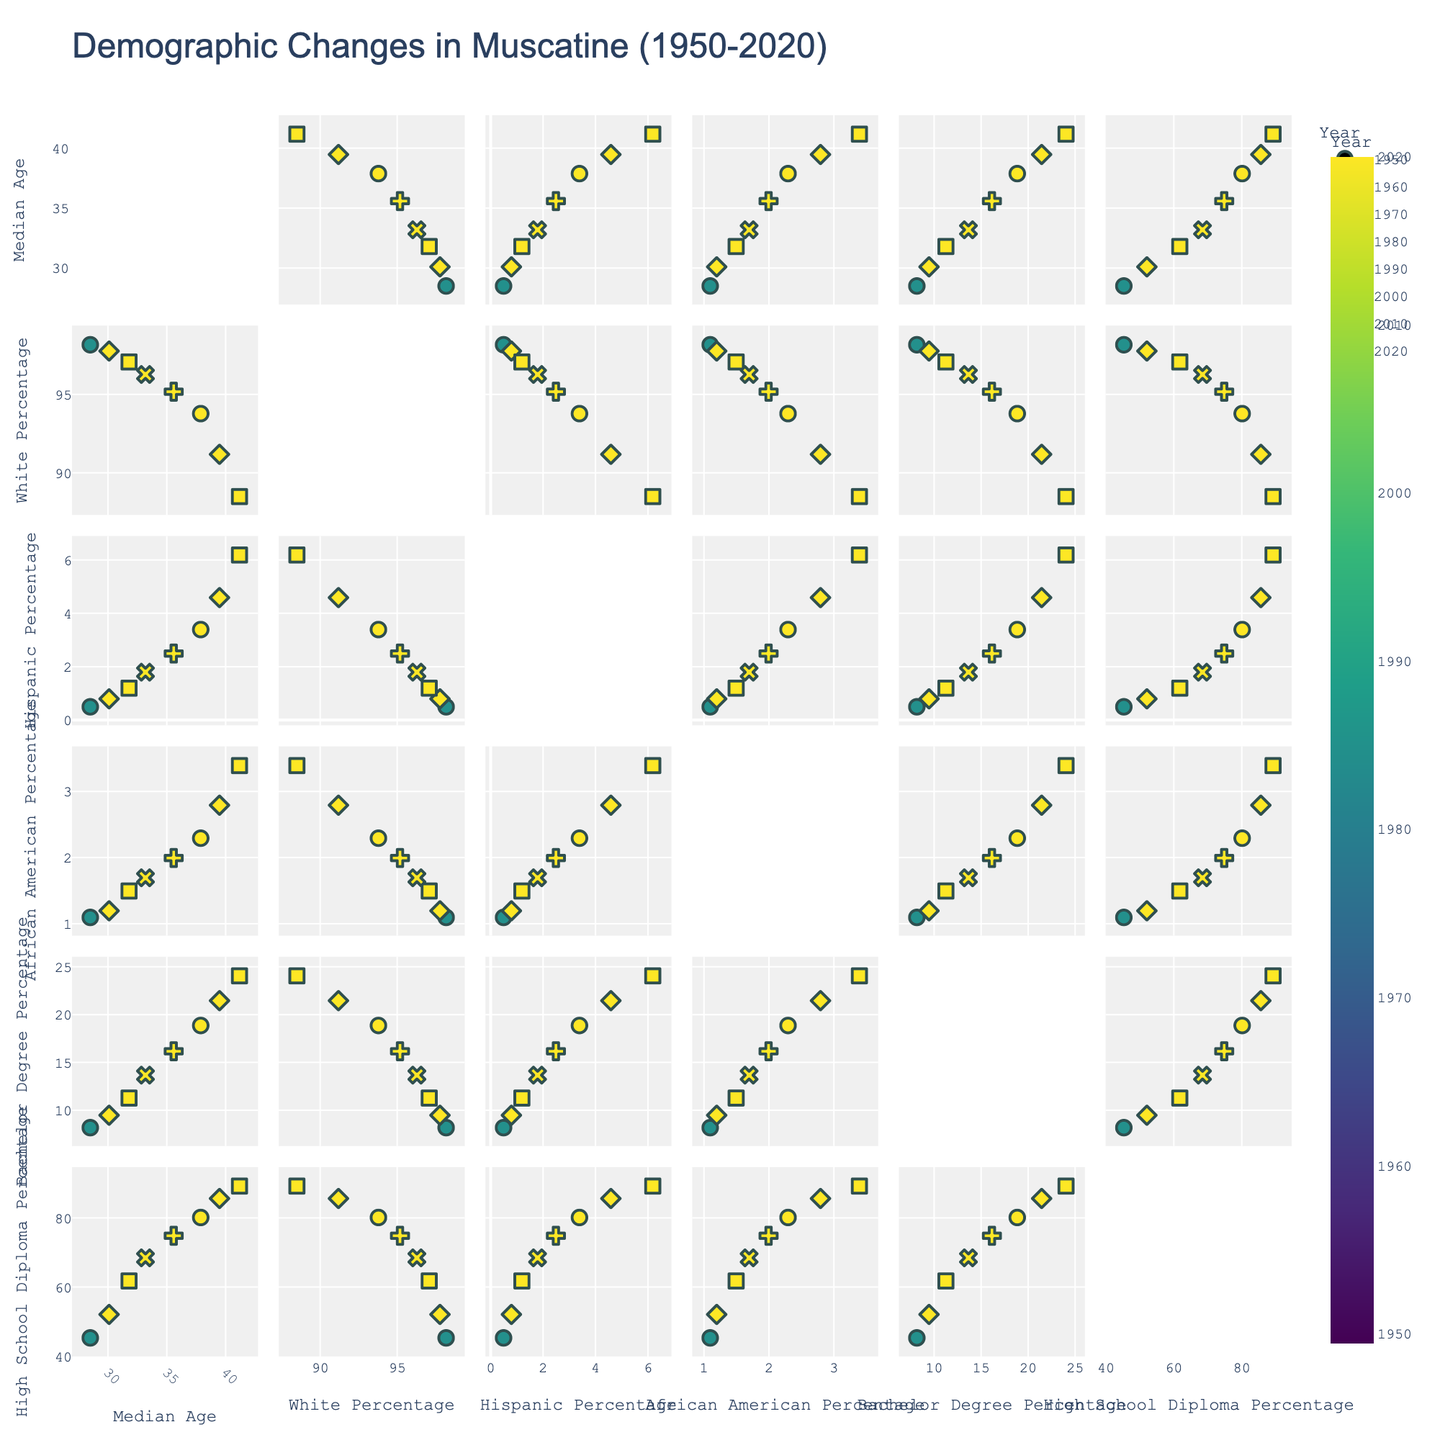What is the title of the figure? The title is generally placed at the top center of the figure.
Answer: Demographic Changes in Muscatine (1950-2020) How many data points are represented in the scatterplot matrix? The scatterplot matrix represents each year as a unique data point. As there are years yearly from 1950 to 2020 in the dataset, there are 8 data points.
Answer: 8 Which year corresponds to the highest percentage of bachelor's degrees? By examining the scatterplot involving "Bachelor's Degree Percentage" on the y-axis, you can find the data point with the highest position. The highest bachelor's degree percentage peaks in the year 2020.
Answer: 2020 Is there a visible trend in the median age over the years? Analyzing the scatter plot of "Median Age" against "Year" reveals that the median age has been progressively increasing over the years.
Answer: Increasing trend Compare the percentage of high school diplomas in 1950 and 2020. What is the difference between them? Locate the data points for years 1950 and 2020 in the scatterplot involving "High School Diploma Percentage." The percentage in 1950 is 45.3%, and in 2020 is 89.3%. The difference is 89.3% - 45.3% = 44%.
Answer: 44% Which ethnic group has seen the most significant growth from 1950 to 2020? Observing the scatter plots for each ethnic group across the years, examine their visible trends. The Hispanic population shows notable growth from 0.5% in 1950 to 6.2% in 2020.
Answer: Hispanic Is there any noticeable correlation between the median age and the percentage of people with a bachelor's degree? By focusing on the scatterplot with "Median Age" on one axis and "Bachelor's Degree Percentage" on the other, we notice that as the median age increases, so does the bachelor's degree percentage, indicating a positive correlation.
Answer: Positive correlation In which decade did the percentage of African Americans experience a notable change? Look at the scatterplot of "African American Percentage" across different years. The percentage notably changes between 1980 and 1990.
Answer: Between 1980 and 1990 How did the percentage of whites change from 1950 to 2020? By identifying the data points in the "White Percentage" scatter plot for 1950 and 2020, we observe the percentage decreased from 98.2% to 88.5%.
Answer: Decreased What is the overall trend shown for high school diploma attainment from 1950 to 2020? Identify the positioning of data points in the "High School Diploma Percentage" scatter plot through the years. The trend shows a consistent increase from 45.3% in 1950 to 89.3% in 2020.
Answer: Increasing trend 